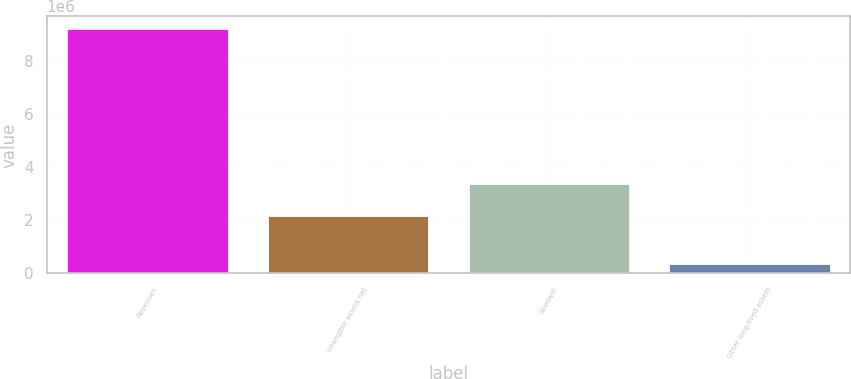Convert chart. <chart><loc_0><loc_0><loc_500><loc_500><bar_chart><fcel>Revenues<fcel>Intangible assets net<fcel>Goodwill<fcel>Other long-lived assets<nl><fcel>9.22399e+06<fcel>2.16753e+06<fcel>3.375e+06<fcel>331127<nl></chart> 